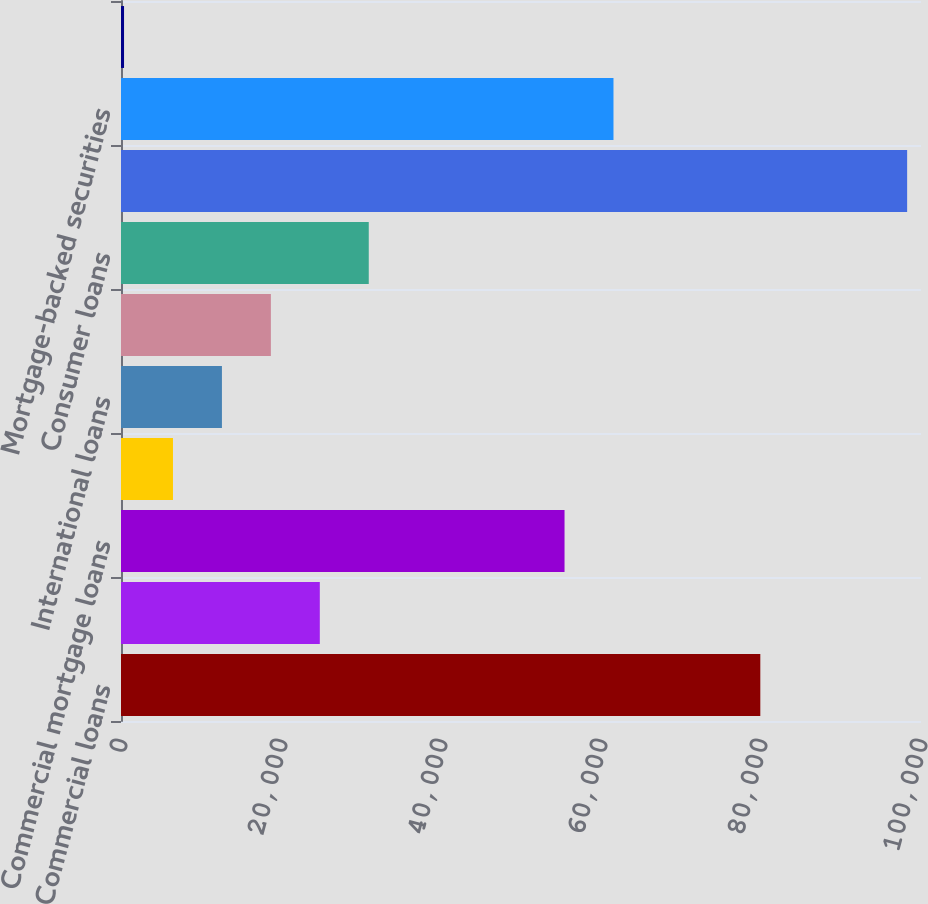<chart> <loc_0><loc_0><loc_500><loc_500><bar_chart><fcel>Commercial loans<fcel>Real estate construction loans<fcel>Commercial mortgage loans<fcel>Lease financing<fcel>International loans<fcel>Residential mortgage loans<fcel>Consumer loans<fcel>Total loans (b) (c)<fcel>Mortgage-backed securities<fcel>Other investment securities<nl><fcel>79914<fcel>24852<fcel>55442<fcel>6498<fcel>12616<fcel>18734<fcel>30970<fcel>98268<fcel>61560<fcel>380<nl></chart> 